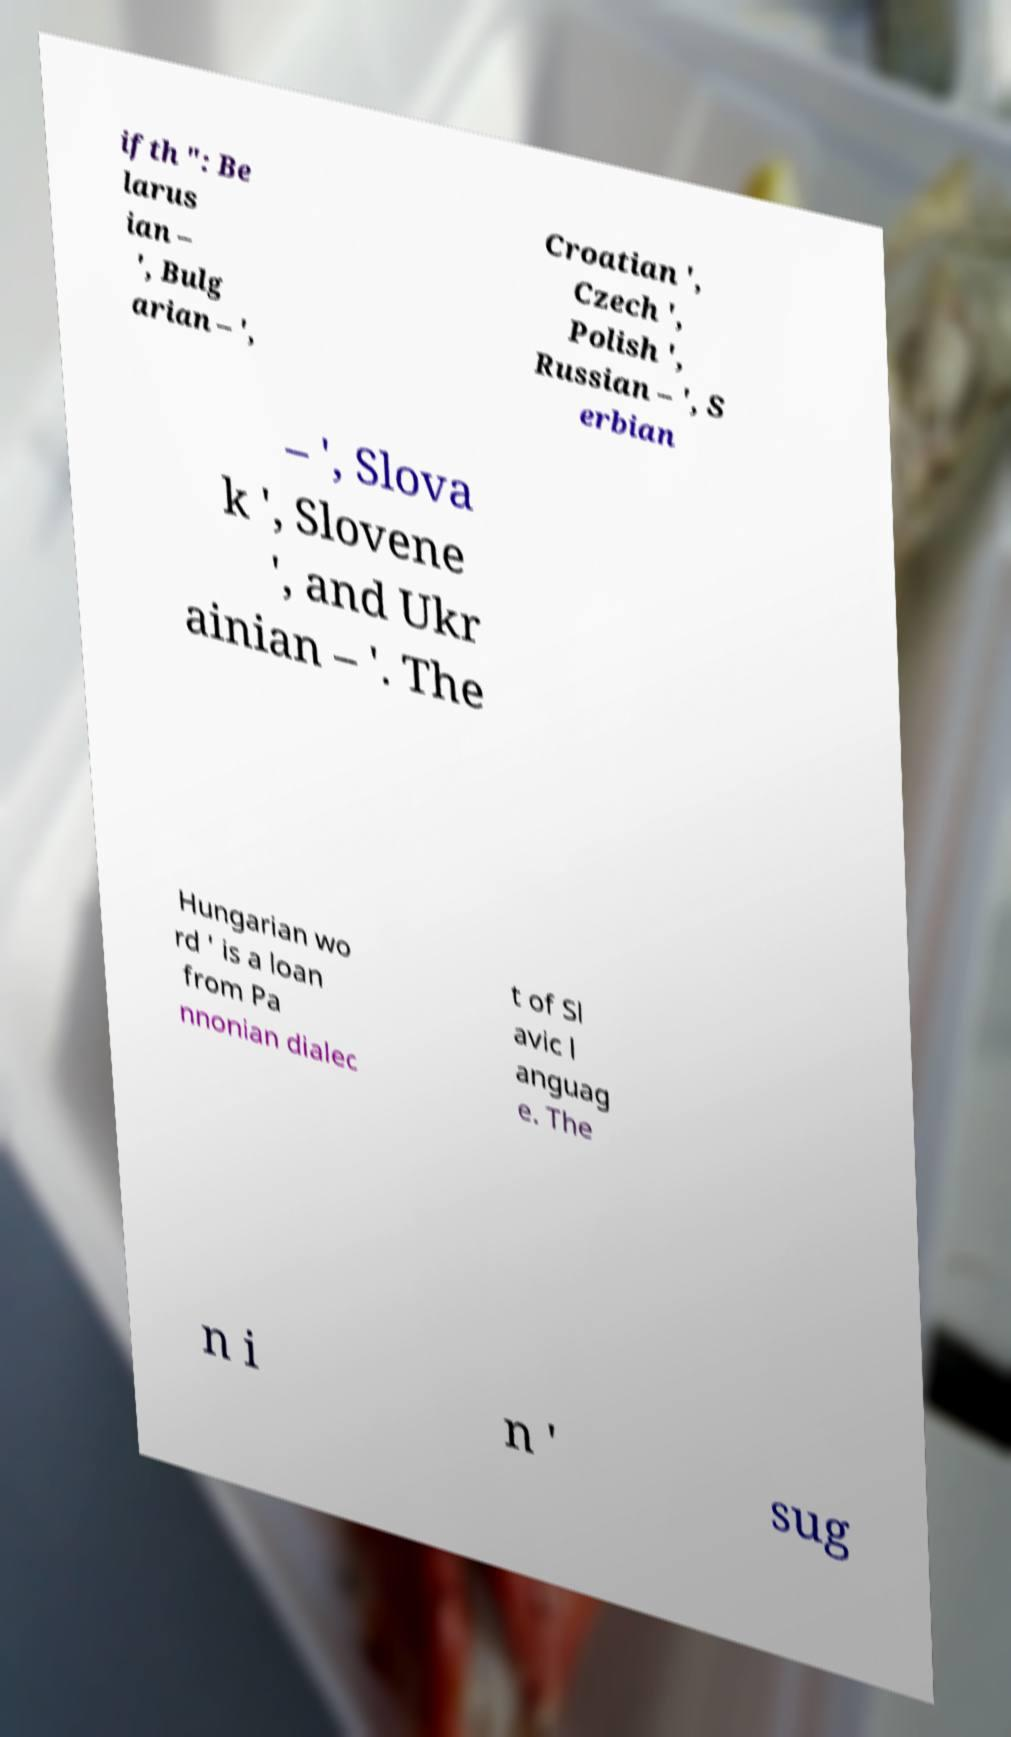For documentation purposes, I need the text within this image transcribed. Could you provide that? ifth ": Be larus ian – ', Bulg arian – ', Croatian ', Czech ', Polish ', Russian – ', S erbian – ', Slova k ', Slovene ', and Ukr ainian – '. The Hungarian wo rd ' is a loan from Pa nnonian dialec t of Sl avic l anguag e. The n i n ' sug 